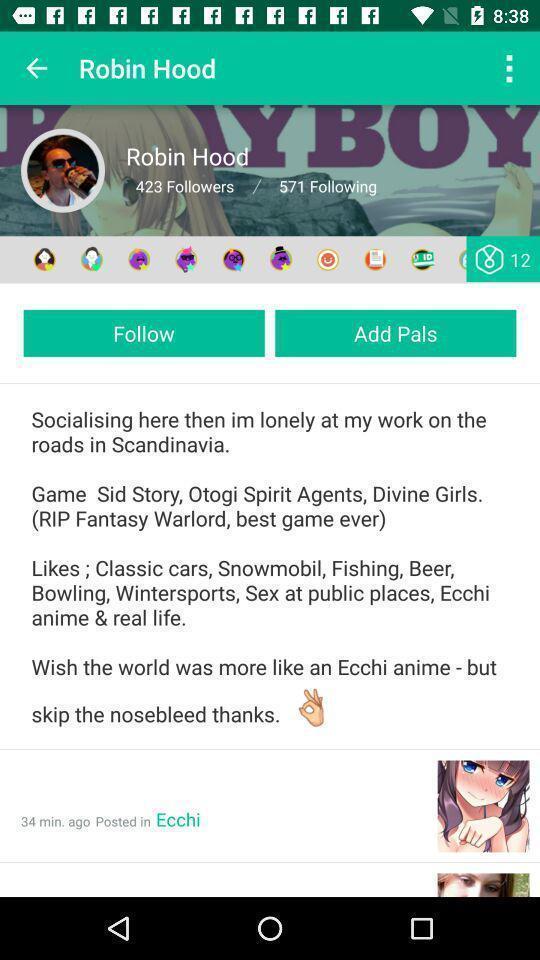Describe this image in words. Screen displaying user profile information. 